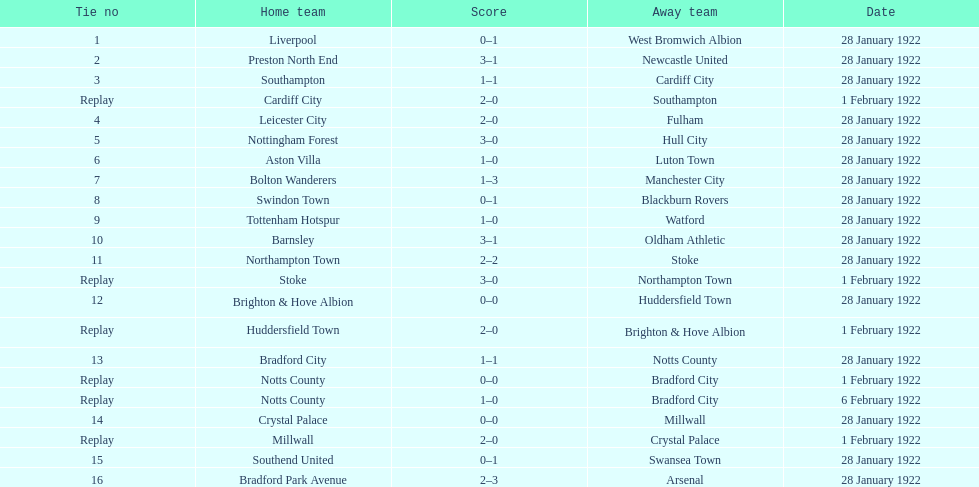In which game was the total number of goals greater, the first or the sixteenth? 16. 